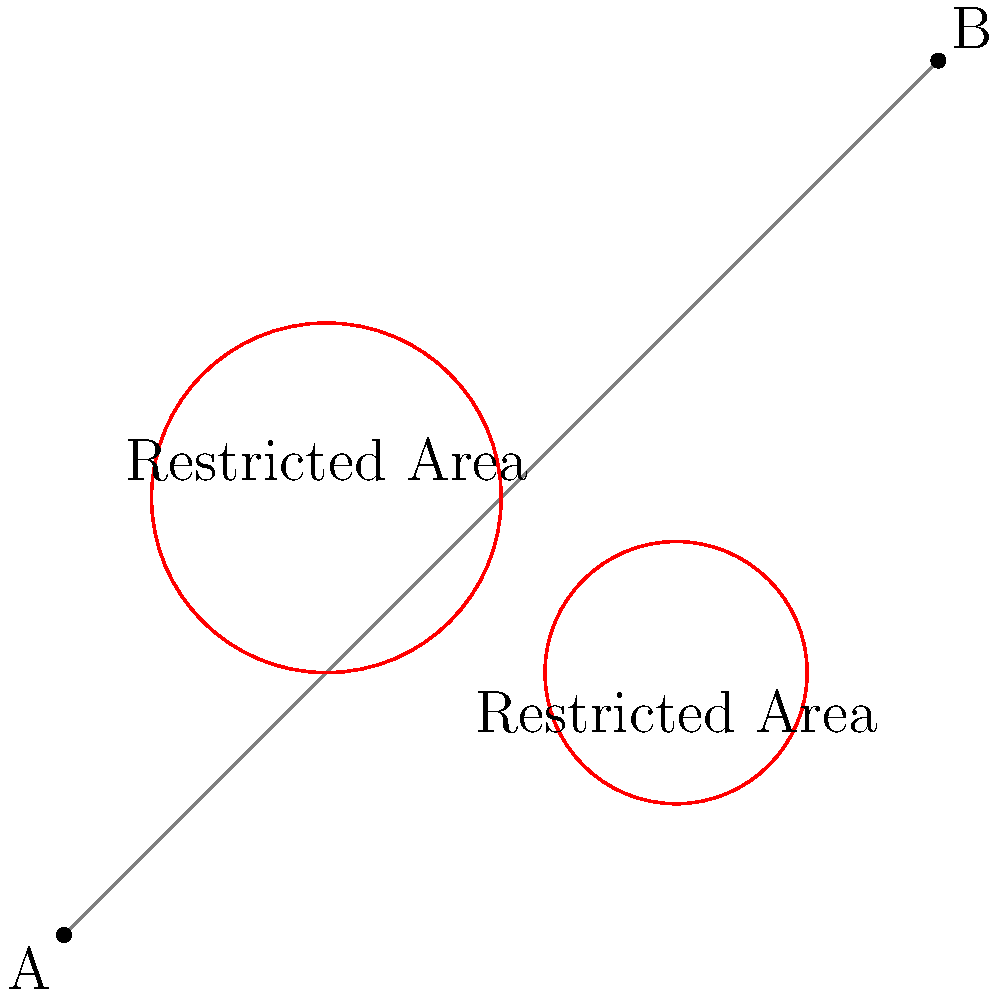As a war correspondent, you need to travel from point A to point B while avoiding restricted areas. Given the map above, where red circles represent dangerous zones, what is the shortest safe path from A to B? Describe the path in terms of its relation to the restricted areas. To find the shortest safe path from A to B, we need to consider the topology of the map and the restricted areas. Here's a step-by-step approach:

1. Observe that a straight line between A and B intersects both restricted areas, making it unsafe.

2. The shortest safe path will be tangent to the restricted areas, as this minimizes the deviation from the straight line while ensuring safety.

3. There are two possible paths:
   a. Passing above both restricted areas
   b. Passing below both restricted areas

4. The path passing above both restricted areas:
   - Starts at A
   - Curves around the top of the first (larger) restricted area
   - Continues tangent to the top of the second (smaller) restricted area
   - Ends at B

5. The path passing below both restricted areas:
   - Starts at A
   - Curves around the bottom of the second (smaller) restricted area
   - Continues tangent to the bottom of the first (larger) restricted area
   - Ends at B

6. Visually, the path passing above both restricted areas appears to be shorter, as it deviates less from the straight line between A and B.

Therefore, the shortest safe path from A to B is the one that passes tangent to the top of both restricted areas.
Answer: The path tangent to the top of both restricted areas 